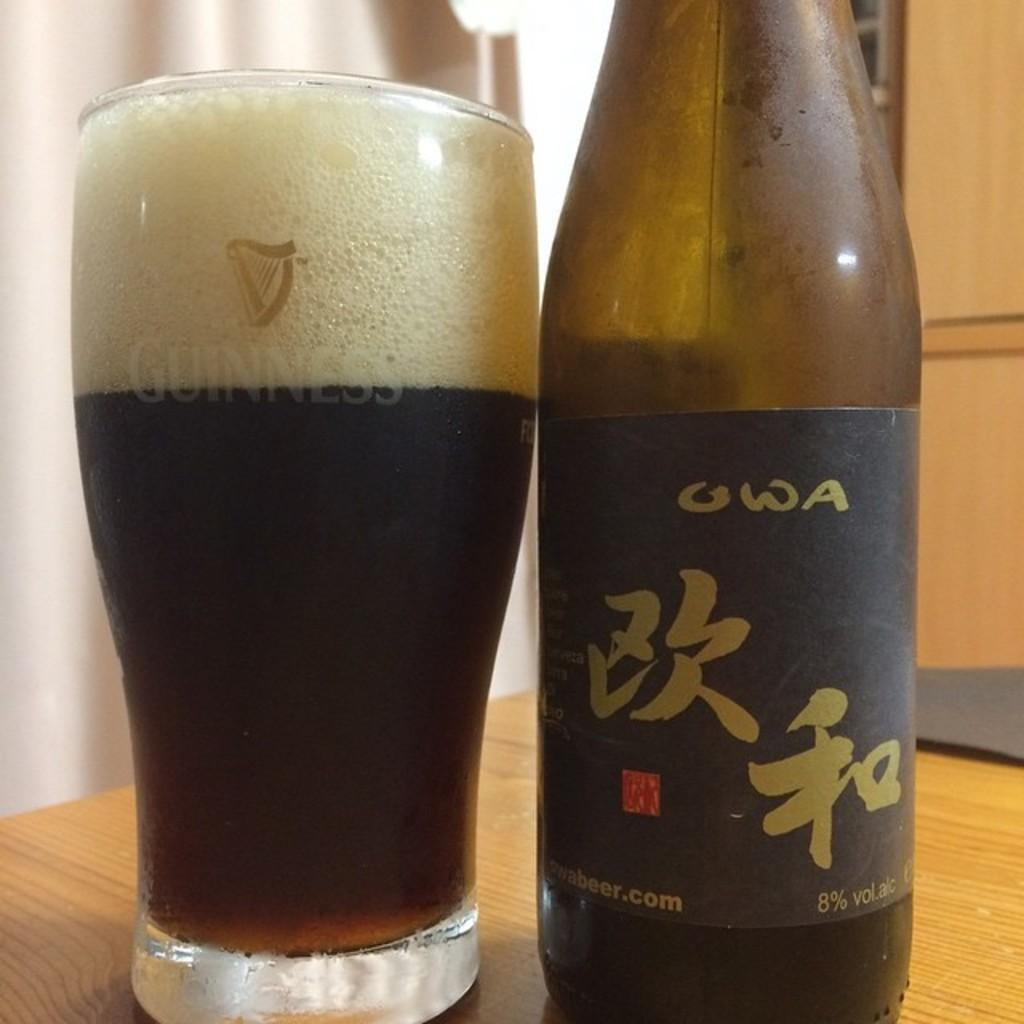What type of beverage is featured in the image? There is a beer bottle with a label and a glass of beer on the table in the image. What can be seen in the background of the image? There is a curtain and a wall in the background of the image. What year is the grandfather's birthday being celebrated in the image? There is no grandfather or birthday celebration present in the image. 